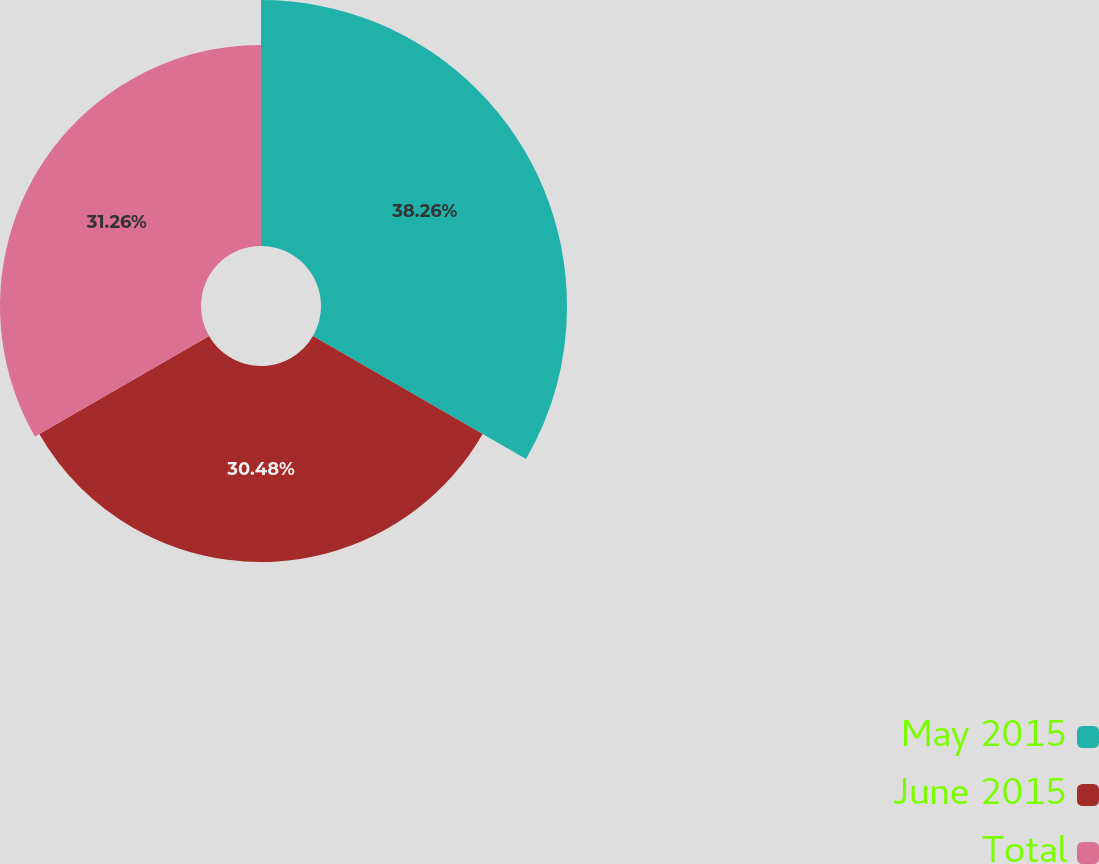Convert chart. <chart><loc_0><loc_0><loc_500><loc_500><pie_chart><fcel>May 2015<fcel>June 2015<fcel>Total<nl><fcel>38.26%<fcel>30.48%<fcel>31.26%<nl></chart> 